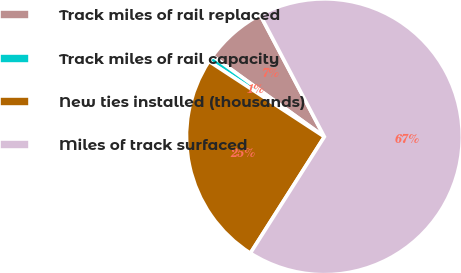Convert chart. <chart><loc_0><loc_0><loc_500><loc_500><pie_chart><fcel>Track miles of rail replaced<fcel>Track miles of rail capacity<fcel>New ties installed (thousands)<fcel>Miles of track surfaced<nl><fcel>7.33%<fcel>0.74%<fcel>25.2%<fcel>66.73%<nl></chart> 